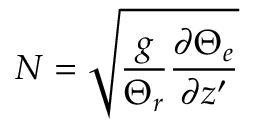Convert formula to latex. <formula><loc_0><loc_0><loc_500><loc_500>N = \sqrt { \frac { g } { \Theta _ { r } } \frac { \partial \Theta _ { e } } { \partial z ^ { \prime } } }</formula> 